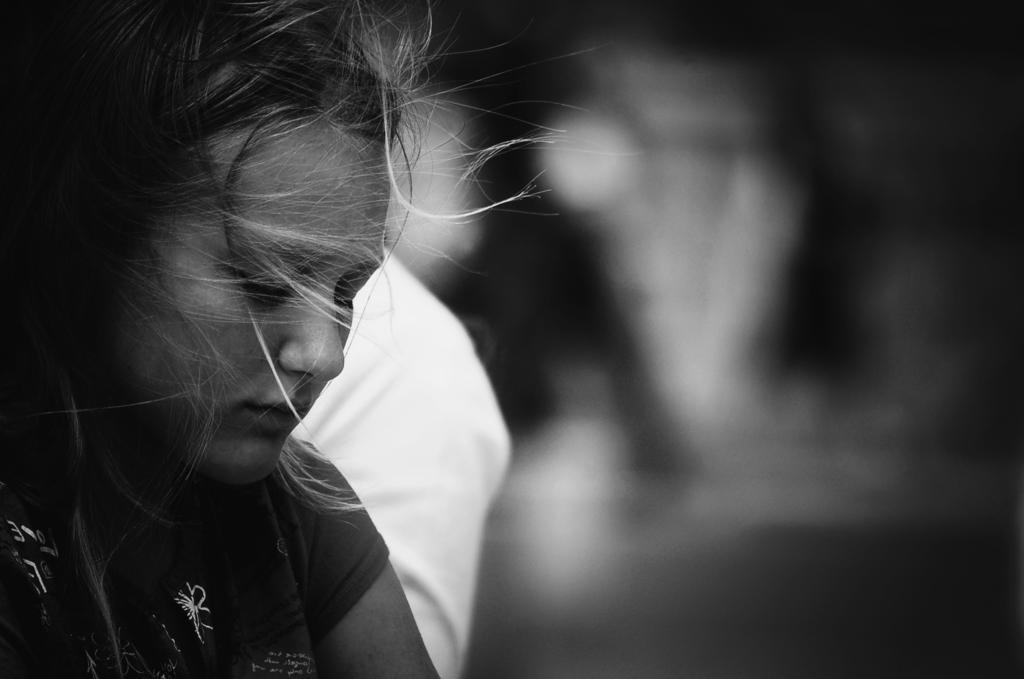Could you give a brief overview of what you see in this image? This is a black and white image. In this image we can see there is a girl. The background is dark. 